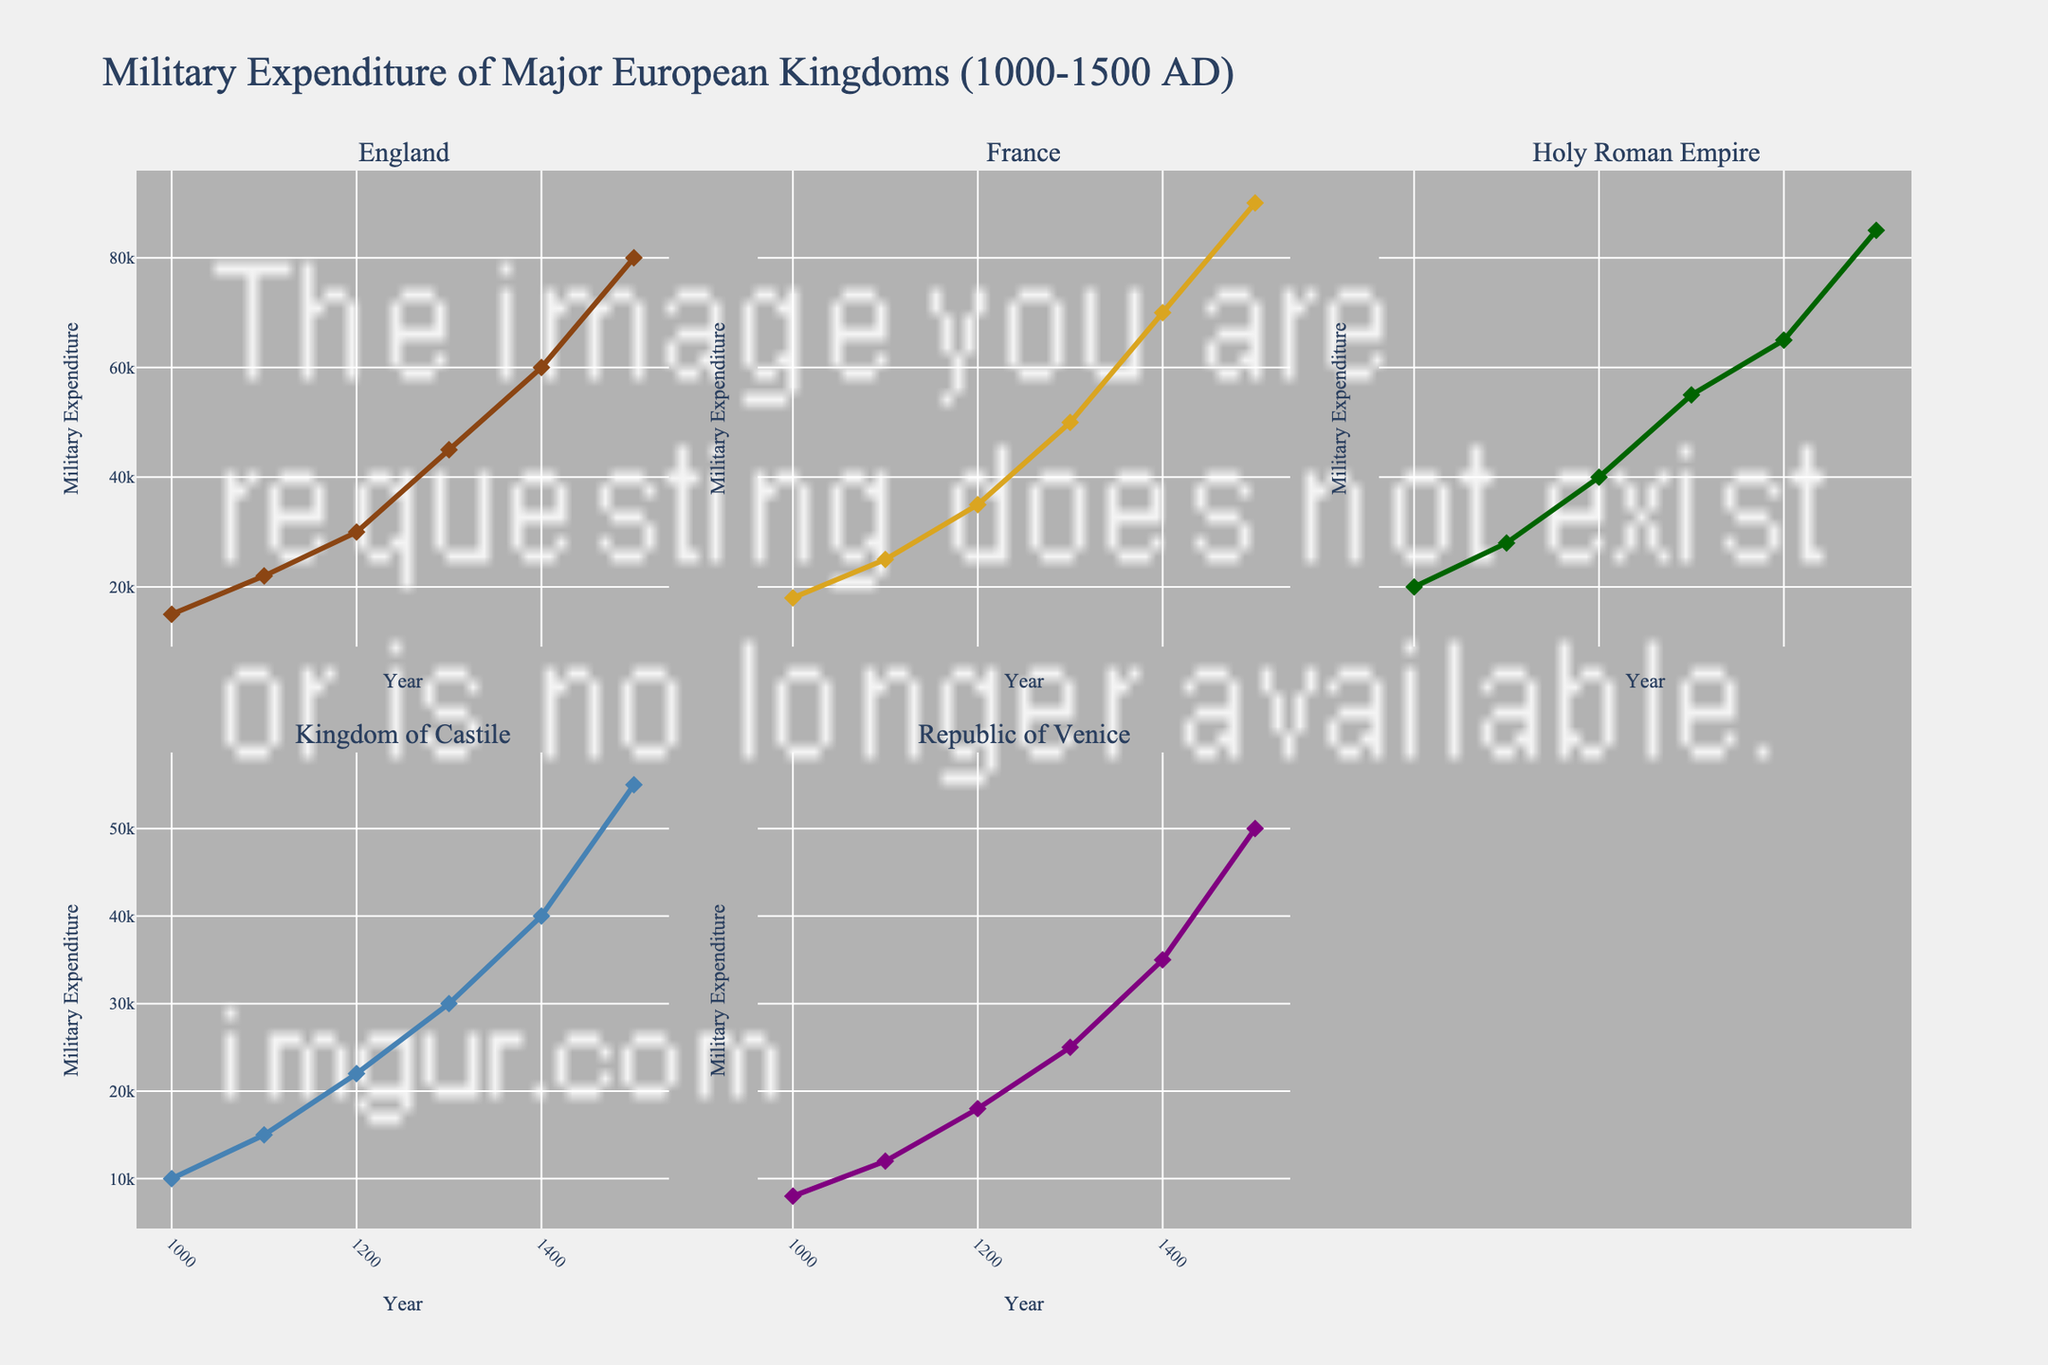What is the trend in military expenditure for England from 1000 to 1500 AD? The trend in England's military expenditure shows a steady increase from 15,000 in 1000 AD to 80,000 in 1500 AD. Each century, the expenditure continues to rise.
Answer: Steady increase Which kingdom has the highest military expenditure in the year 1200 AD? Observing the data points for the year 1200 AD, the Holy Roman Empire has the highest military expenditure at 40,000.
Answer: Holy Roman Empire What is the difference in military expenditure between the Republic of Venice and the Kingdom of Castile in 1400 AD? In 1400, the Republic of Venice's expenditure is 35,000 while the Kingdom of Castile's is 40,000. The difference is calculated as 40,000 - 35,000 = 5,000.
Answer: 5,000 Between 1300 and 1400 AD, which kingdom saw the largest increase in military expenditure? Considering the data between 1300 and 1400, we calculate the increase for each kingdom. England: 60,000 - 45,000 = 15,000; France: 70,000 - 50,000 = 20,000; Holy Roman Empire: 65,000 - 55,000 = 10,000; Kingdom of Castile: 40,000 - 30,000 = 10,000; Republic of Venice: 35,000 - 25,000 = 10,000. France has the largest increase of 20,000.
Answer: France Which kingdom had the lowest military expenditure in the year 1100 AD? Looking at the data for 1100 AD, the Republic of Venice has the lowest expenditure with 12,000.
Answer: Republic of Venice How does the military expenditure of France in 1500 AD compare to that of the Holy Roman Empire? In 1500 AD, France's military expenditure is 90,000, while the Holy Roman Empire's is 85,000. Therefore, France's expenditure is higher.
Answer: Higher What is the average military expenditure of the Kingdom of Castile over the entire period? Adding up the expenditures for all periods (10,000 + 15,000 + 22,000 + 30,000 + 40,000 + 55,000) gives 172,000. Dividing by the number of periods (6) gives an average of 28,666.67.
Answer: 28,666.67 What can be observed from the military expenditure trends of the kingdoms in the 1400s? For the 1400s, England, France, and the Holy Roman Empire all record significant increases compared to previous centuries. This period marks the highest expenditures observed for the entire dataset.
Answer: Significant increases 